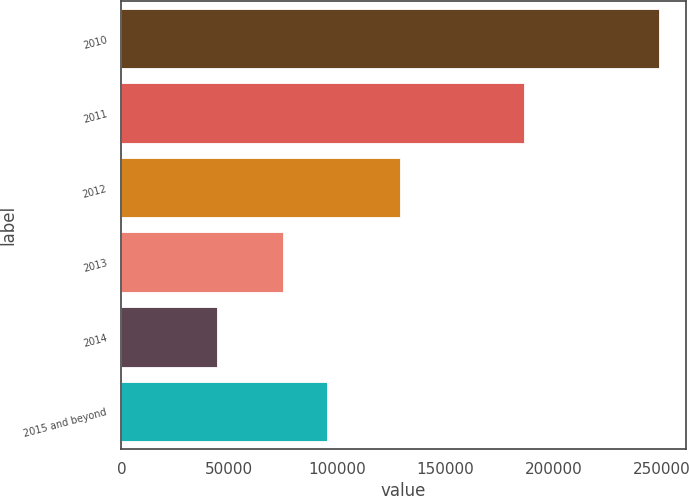<chart> <loc_0><loc_0><loc_500><loc_500><bar_chart><fcel>2010<fcel>2011<fcel>2012<fcel>2013<fcel>2014<fcel>2015 and beyond<nl><fcel>248712<fcel>186389<fcel>128874<fcel>74714<fcel>44145<fcel>95170.7<nl></chart> 